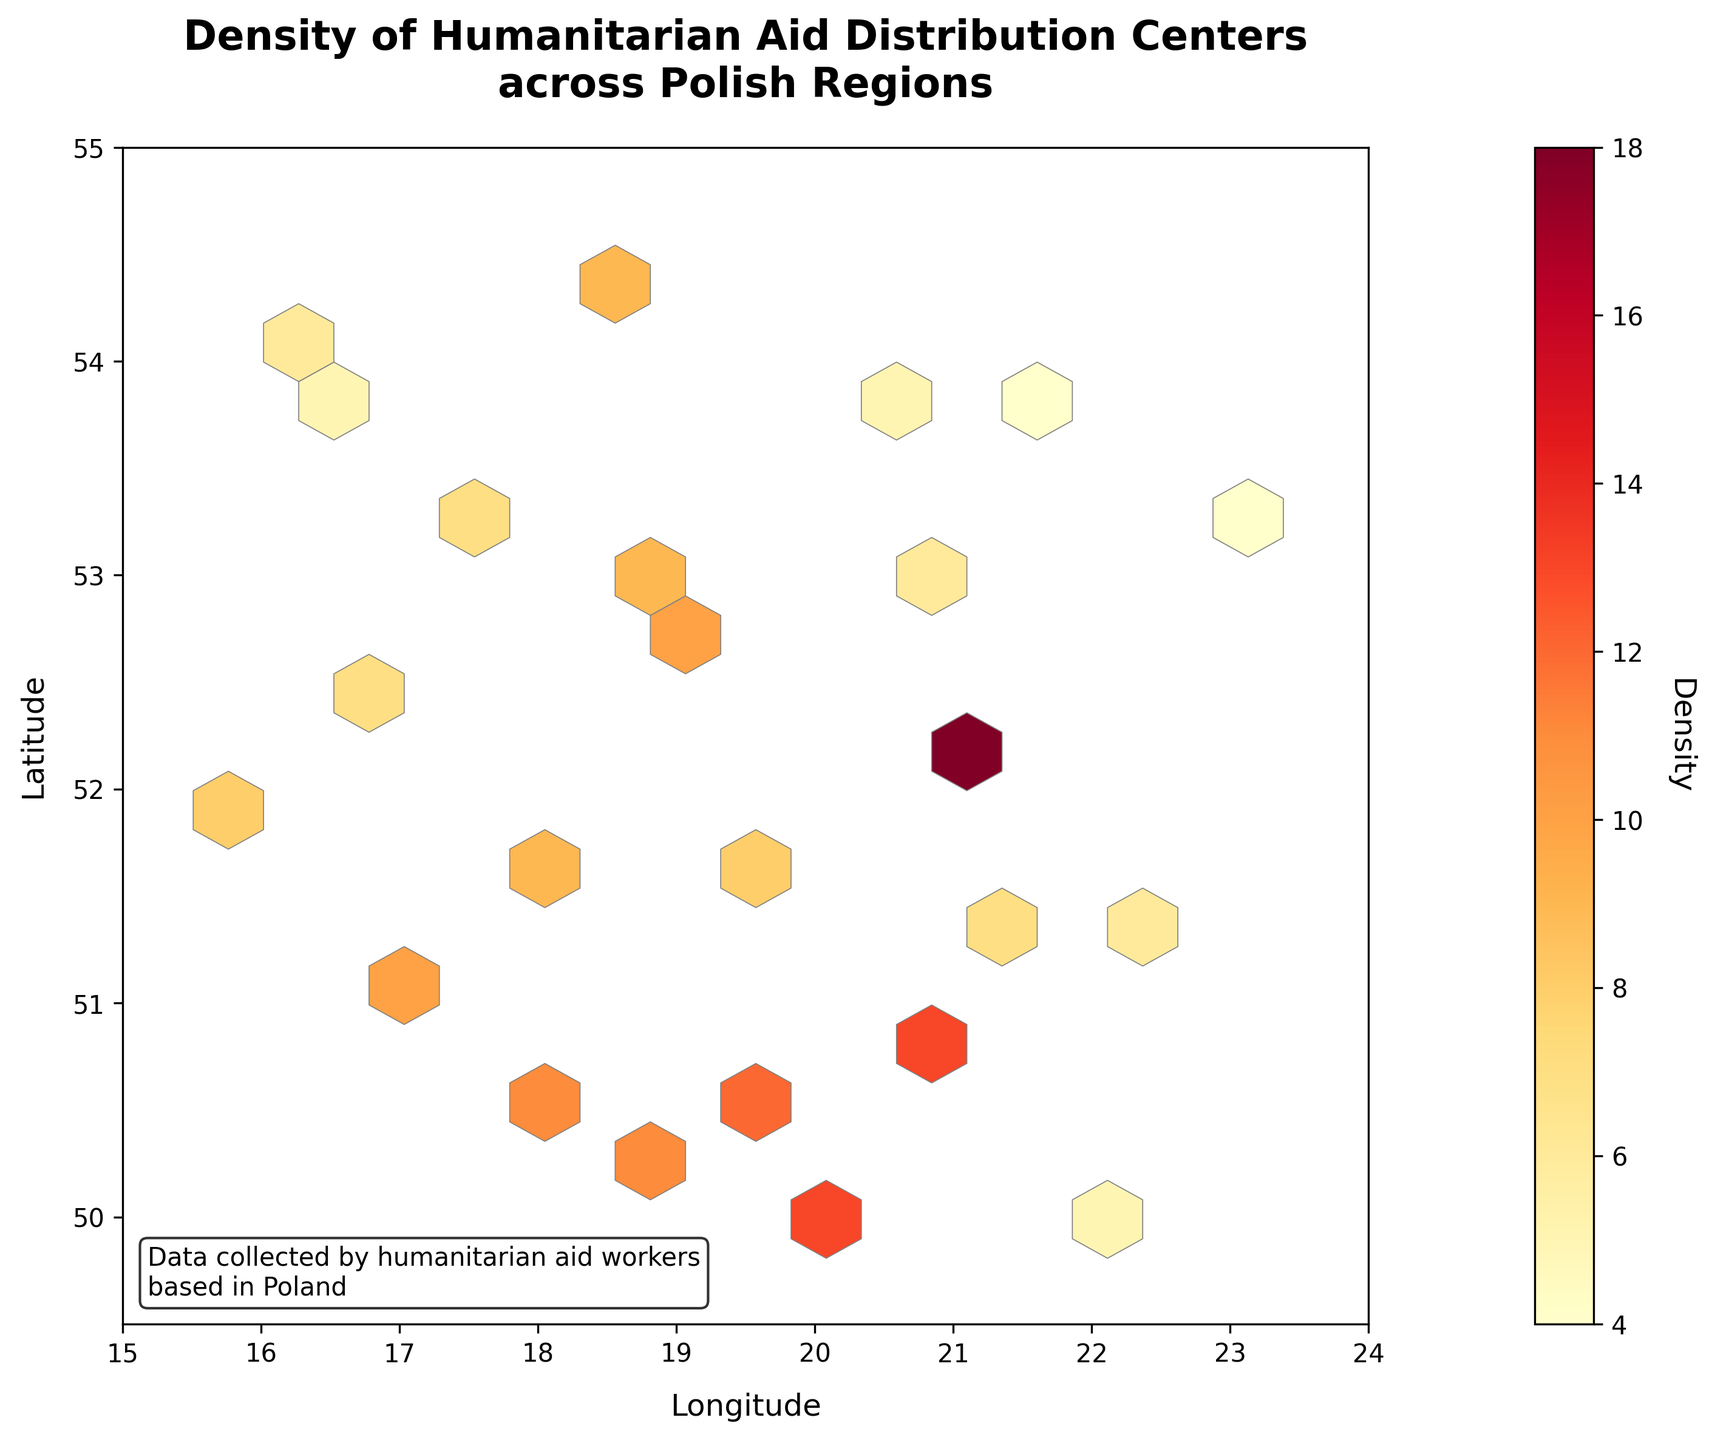What is the title of the figure? The title is located at the top of the figure and emphasizes the main subject of the plot. The title of the figure is "Density of Humanitarian Aid Distribution Centers across Polish Regions."
Answer: Density of Humanitarian Aid Distribution Centers across Polish Regions What information is displayed on the x-axis and y-axis? The x-axis displays the "Longitude," and the y-axis displays the "Latitude." These labels are found along the respective axes.
Answer: Longitude and Latitude What is the color representing in the figure, and how is this information conveyed? The color in the hexbin plot represents the density of humanitarian aid distribution centers. This information is conveyed through a color gradient ranging from yellow to red, with a colorbar on the right side indicating the density values.
Answer: Density What is the highest density value represented in the plot? The highest density value can be identified by looking at the darkest red regions in the hexbin plot. According to the colorbar, the highest density is 18.
Answer: 18 Which longitude range has the most dense concentration of humanitarian aid distribution centers? By observing the cluster of the highest density cells and referring to the x-axis, the dense concentration appears to be around longitude 19 to 21.
Answer: 19 to 21 How does the density change as you move from the bottom-left to the top-right of the plot? As you move from the bottom-left (low longitude and low latitude) to the top-right (high longitude and high latitude), the density generally decreases. Most high-density points are concentrated in the central region.
Answer: Decreases Compare the density of humanitarian aid distribution centers around latitude 50 and longitude 19 to latitude 54 and longitude 17. Which area appears more dense? Refer to the hexagons at the given coordinates and their color. The hexagons around 50 latitude and 19 longitude are darker (red), indicating higher density. The hexagons around 54 latitude and 17 longitude are lighter (yellow/orange), indicating lower density.
Answer: Area around latitude 50 and longitude 19 What is the density value at coordinates approximately 20.62 longitude and 50.87 latitude? Find the approximate location on the plot and refer to the color shade. According to the color scale, the hexagon at these coordinates is a mid-red color representing a density of 13.
Answer: 13 